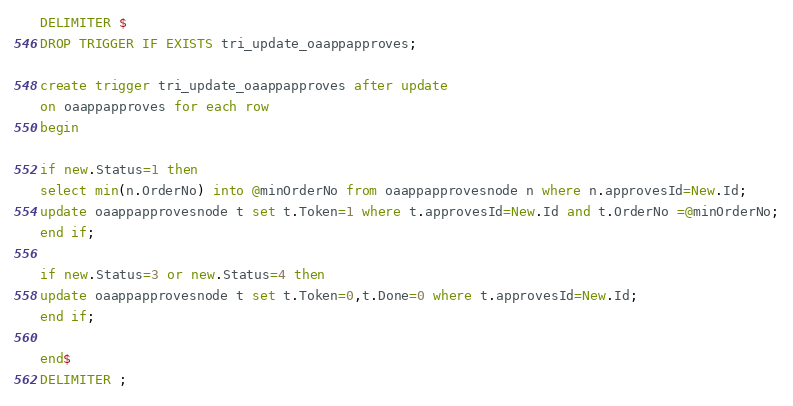Convert code to text. <code><loc_0><loc_0><loc_500><loc_500><_SQL_>DELIMITER $
DROP TRIGGER IF EXISTS tri_update_oaappapproves;

create trigger tri_update_oaappapproves after update
on oaappapproves for each row
begin

if new.Status=1 then
select min(n.OrderNo) into @minOrderNo from oaappapprovesnode n where n.approvesId=New.Id;
update oaappapprovesnode t set t.Token=1 where t.approvesId=New.Id and t.OrderNo =@minOrderNo;
end if;

if new.Status=3 or new.Status=4 then
update oaappapprovesnode t set t.Token=0,t.Done=0 where t.approvesId=New.Id;
end if;

end$
DELIMITER ;</code> 